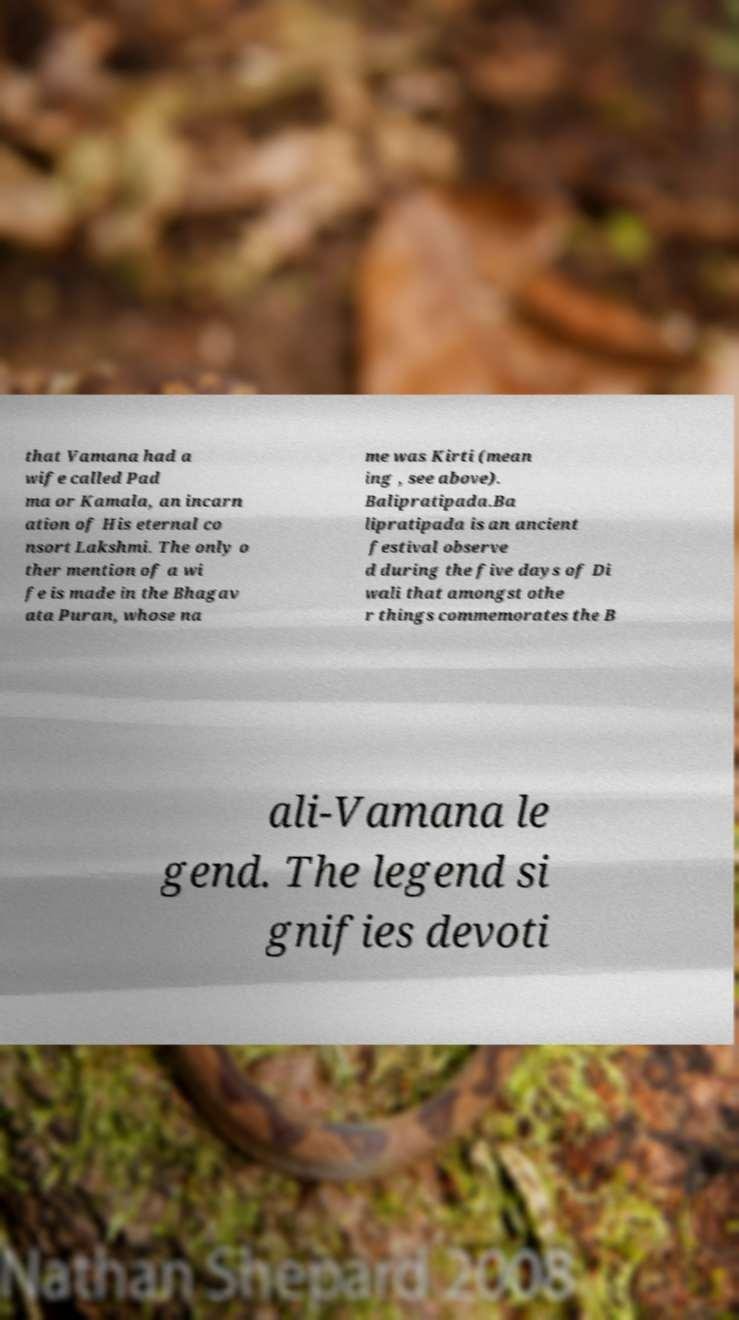I need the written content from this picture converted into text. Can you do that? that Vamana had a wife called Pad ma or Kamala, an incarn ation of His eternal co nsort Lakshmi. The only o ther mention of a wi fe is made in the Bhagav ata Puran, whose na me was Kirti (mean ing , see above). Balipratipada.Ba lipratipada is an ancient festival observe d during the five days of Di wali that amongst othe r things commemorates the B ali-Vamana le gend. The legend si gnifies devoti 